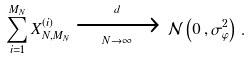<formula> <loc_0><loc_0><loc_500><loc_500>\sum _ { i = 1 } ^ { M _ { N } } X _ { N , M _ { N } } ^ { ( i ) } \xrightarrow [ N \to \infty ] { d } \, \mathcal { N } \left ( 0 \, , \sigma _ { \varphi } ^ { 2 } \right ) \, .</formula> 